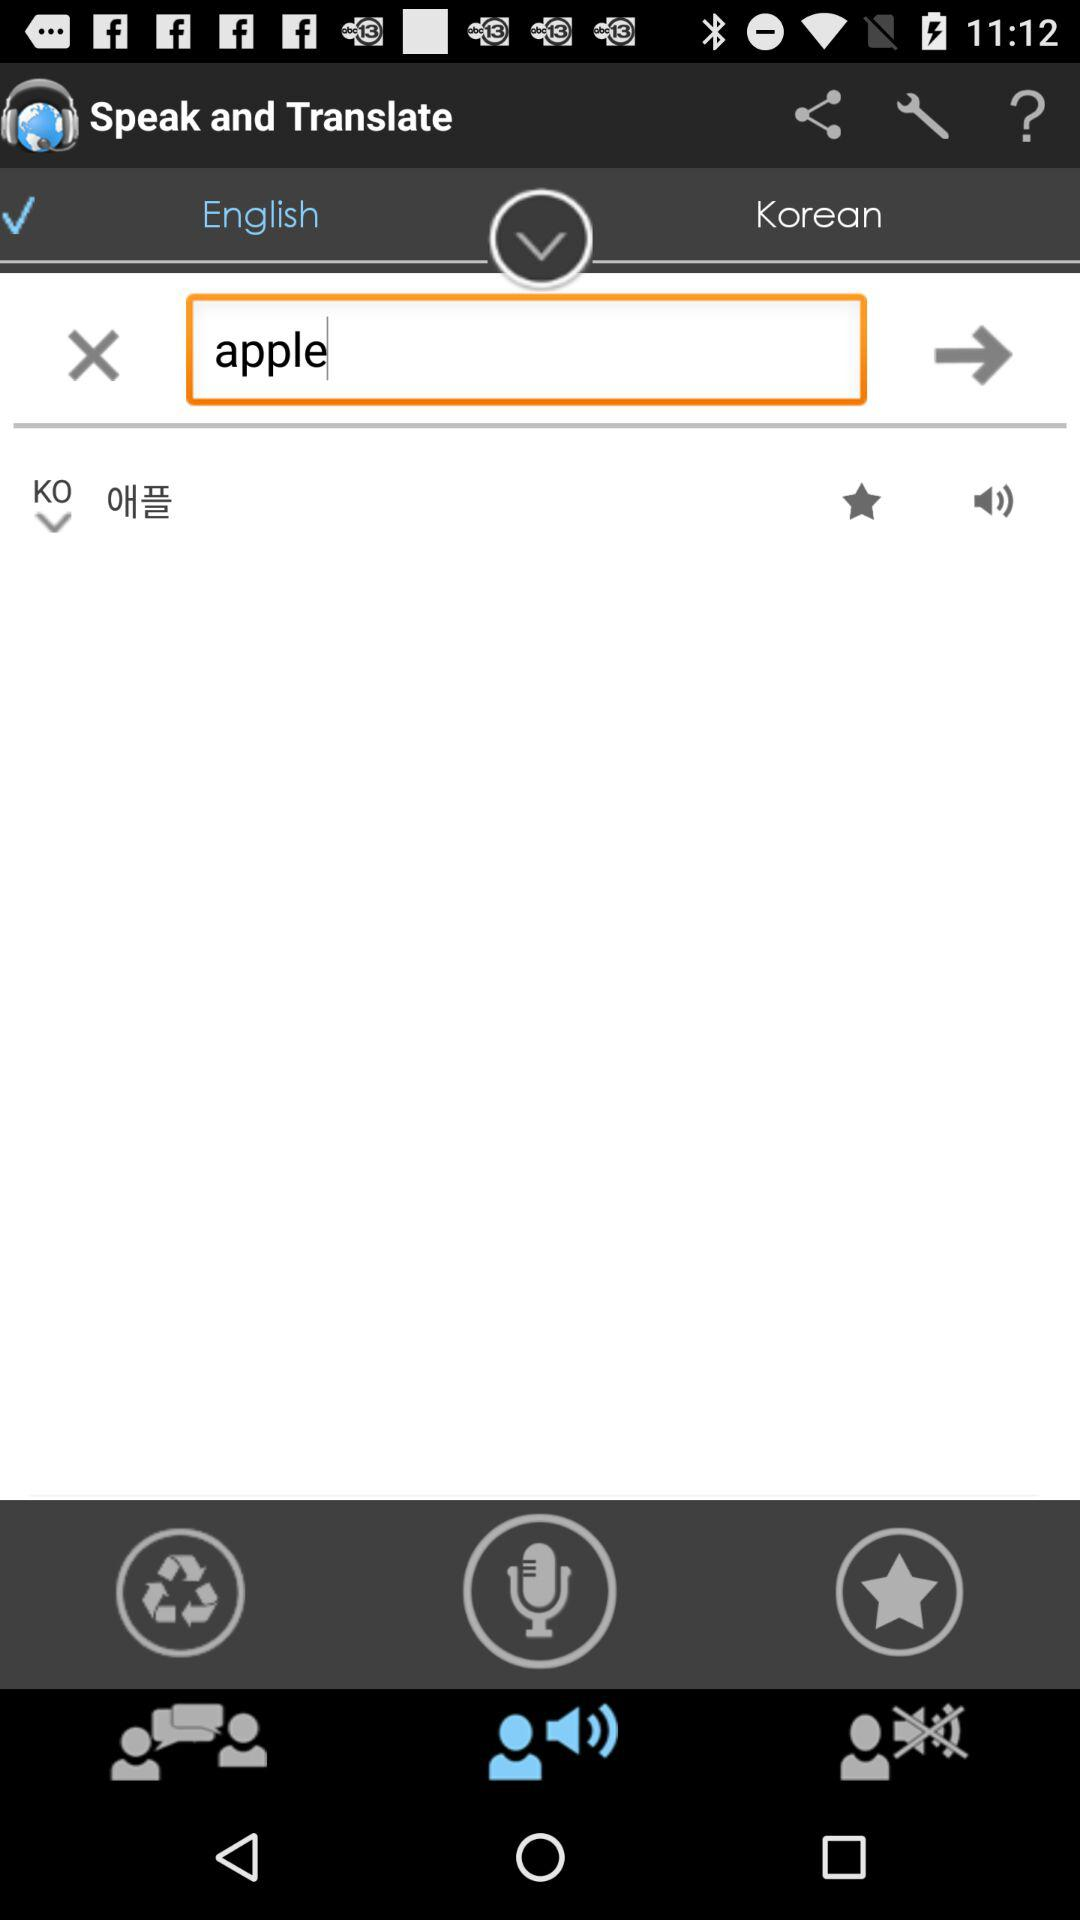For what word does the person want the translation? The word is "apple". 